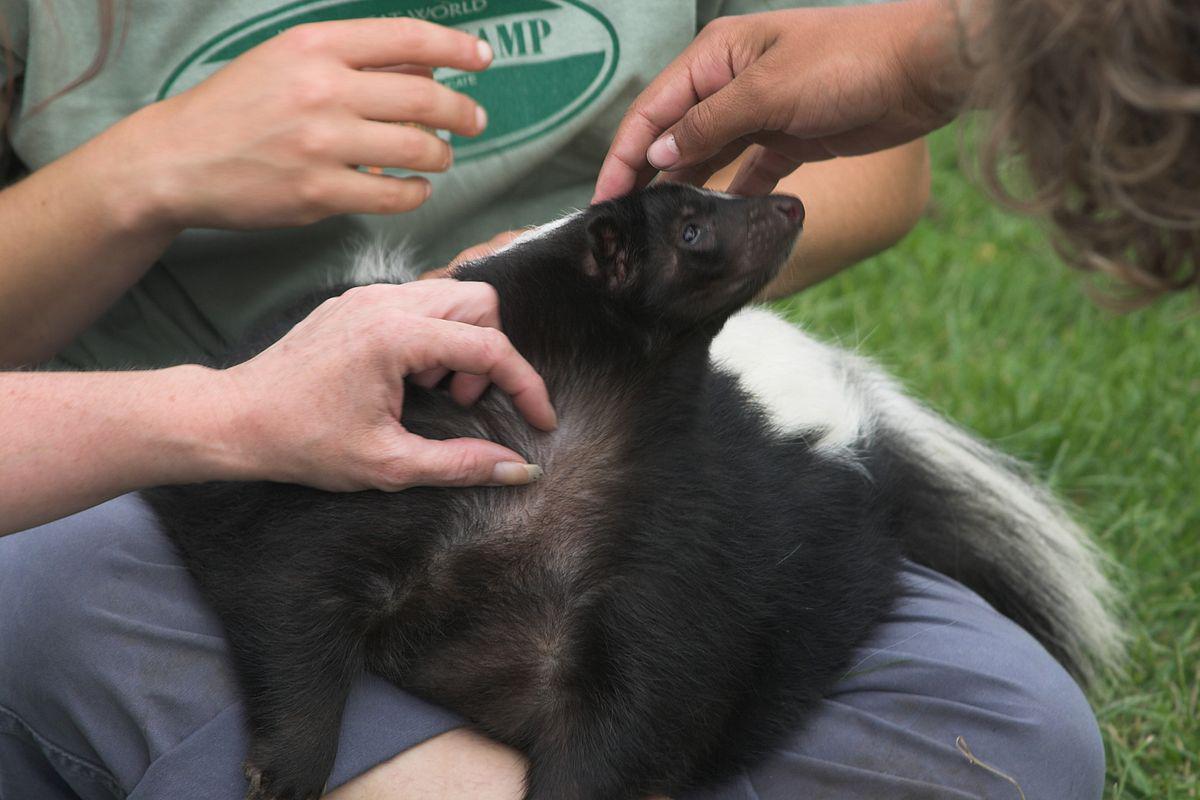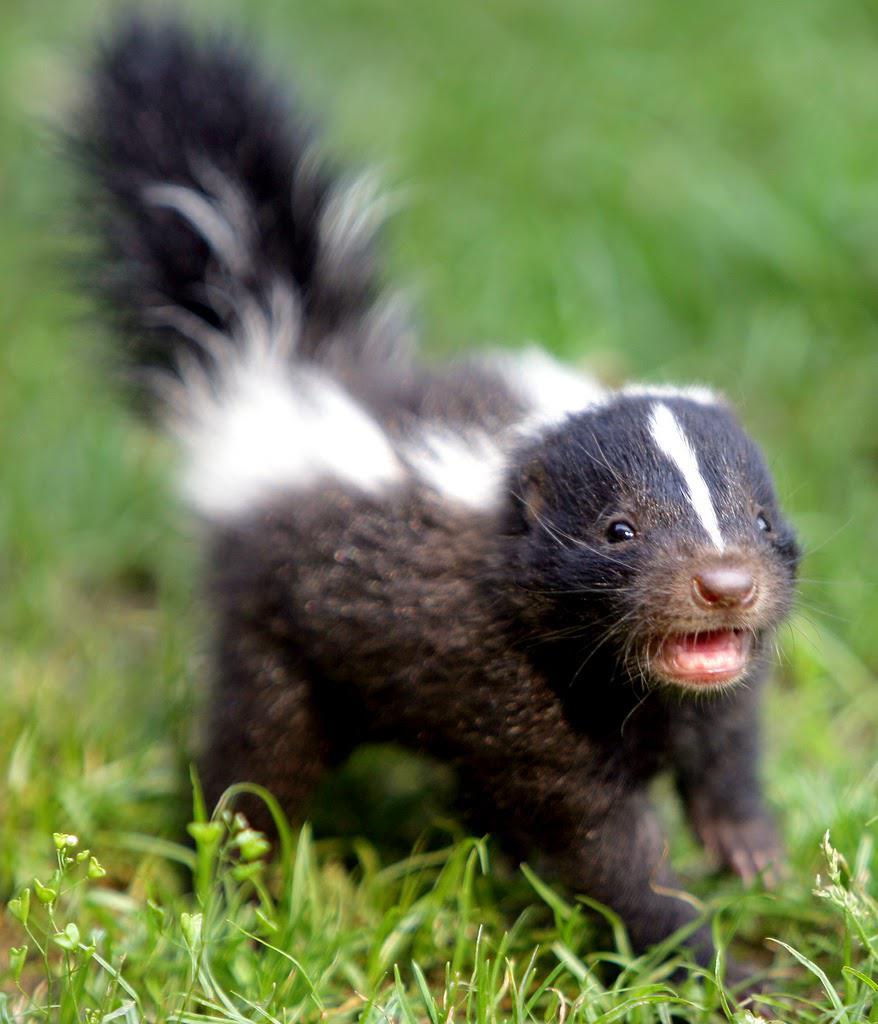The first image is the image on the left, the second image is the image on the right. Considering the images on both sides, is "The left image contains at least one skunk in basket." valid? Answer yes or no. No. The first image is the image on the left, the second image is the image on the right. For the images displayed, is the sentence "At least one camera-gazing skunk has both its front paws on the edge of a basket." factually correct? Answer yes or no. No. 